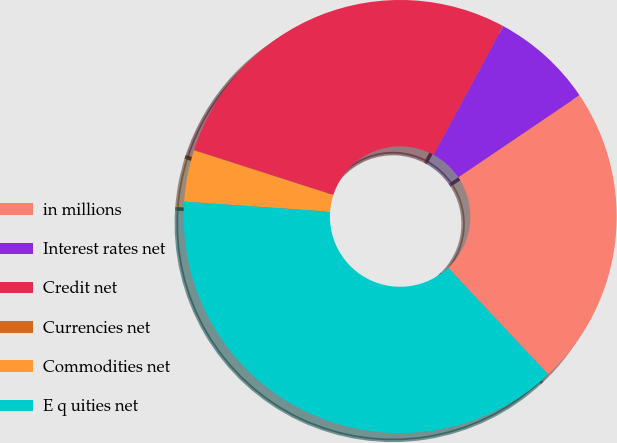Convert chart. <chart><loc_0><loc_0><loc_500><loc_500><pie_chart><fcel>in millions<fcel>Interest rates net<fcel>Credit net<fcel>Currencies net<fcel>Commodities net<fcel>E q uities net<nl><fcel>22.48%<fcel>7.64%<fcel>27.92%<fcel>0.03%<fcel>3.84%<fcel>38.09%<nl></chart> 